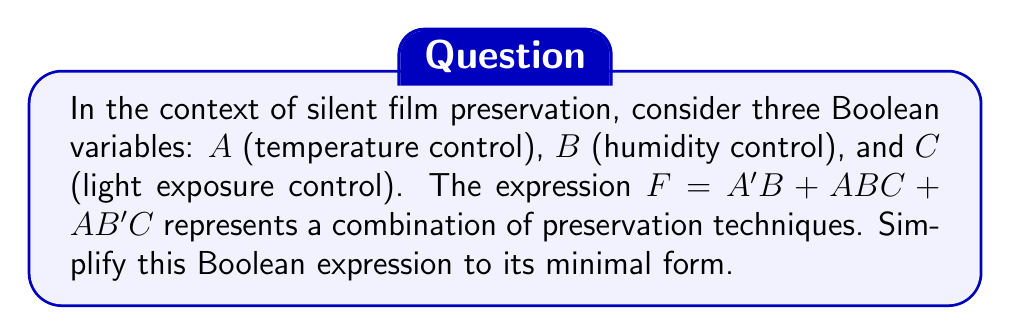Show me your answer to this math problem. Let's simplify the expression $F = A'B + ABC + AB'C$ step-by-step:

1) First, let's apply the distributive law to the term $ABC$:
   $F = A'B + ABC + AB'C$
   $F = A'B + AB(C + C')$

2) Since $C + C' = 1$ (law of complements), we can simplify:
   $F = A'B + AB(1)$
   $F = A'B + AB$

3) Now we can factor out $B$:
   $F = B(A' + A)$

4) Since $A' + A = 1$ (law of complements), we can further simplify:
   $F = B(1)$
   $F = B$

This simplification suggests that in this particular preservation model, humidity control (B) is the most critical factor, regardless of temperature or light exposure control.
Answer: $F = B$ 